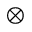Convert formula to latex. <formula><loc_0><loc_0><loc_500><loc_500>\bigotimes</formula> 